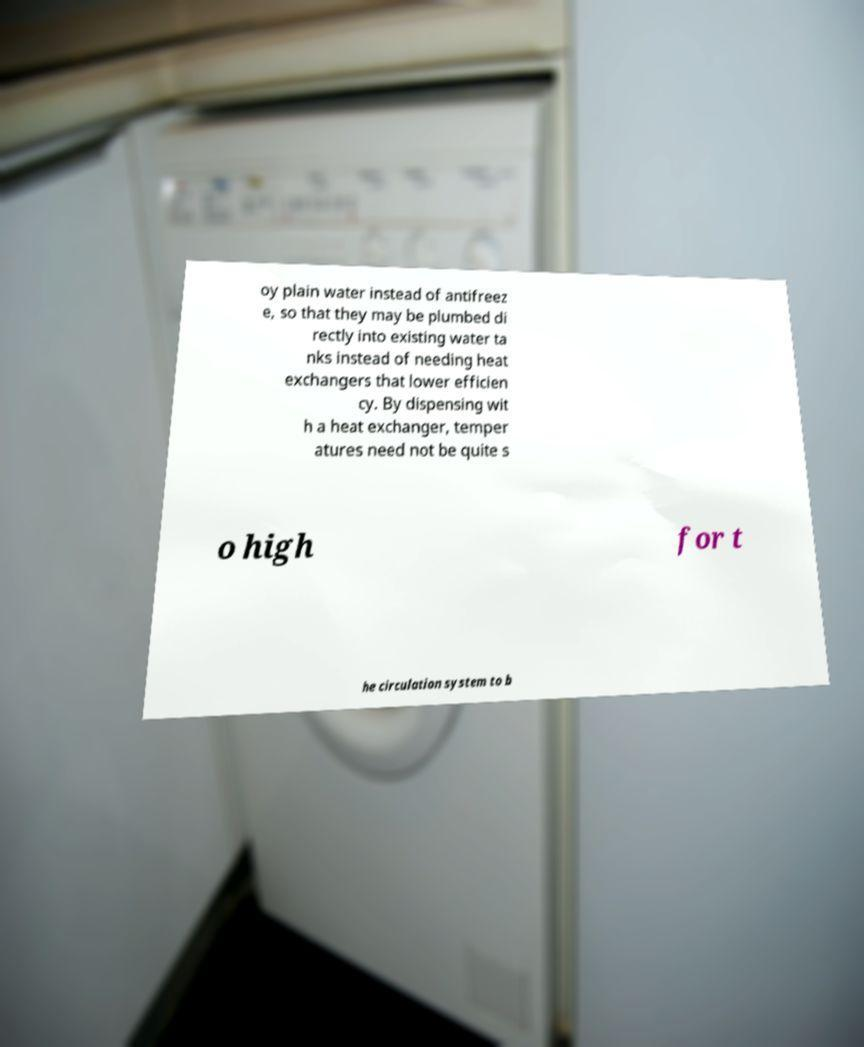Please identify and transcribe the text found in this image. oy plain water instead of antifreez e, so that they may be plumbed di rectly into existing water ta nks instead of needing heat exchangers that lower efficien cy. By dispensing wit h a heat exchanger, temper atures need not be quite s o high for t he circulation system to b 